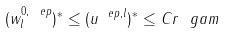Convert formula to latex. <formula><loc_0><loc_0><loc_500><loc_500>( w ^ { 0 , \ e p } _ { l } ) ^ { * } \leq ( u ^ { \ e p , l } ) ^ { * } \leq C r ^ { \ } g a m</formula> 